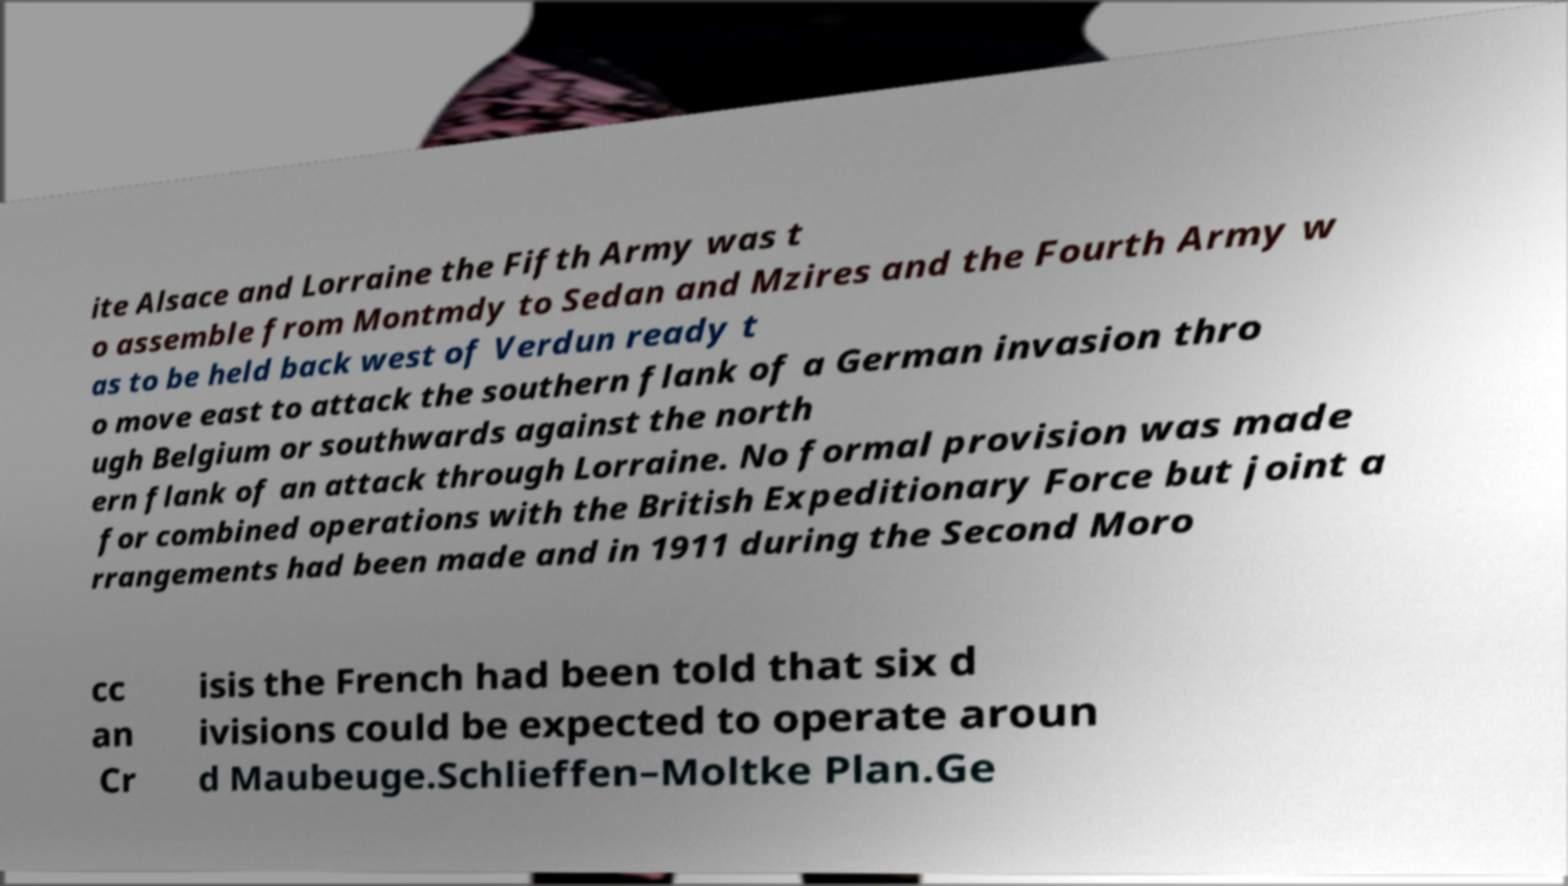Could you extract and type out the text from this image? ite Alsace and Lorraine the Fifth Army was t o assemble from Montmdy to Sedan and Mzires and the Fourth Army w as to be held back west of Verdun ready t o move east to attack the southern flank of a German invasion thro ugh Belgium or southwards against the north ern flank of an attack through Lorraine. No formal provision was made for combined operations with the British Expeditionary Force but joint a rrangements had been made and in 1911 during the Second Moro cc an Cr isis the French had been told that six d ivisions could be expected to operate aroun d Maubeuge.Schlieffen–Moltke Plan.Ge 